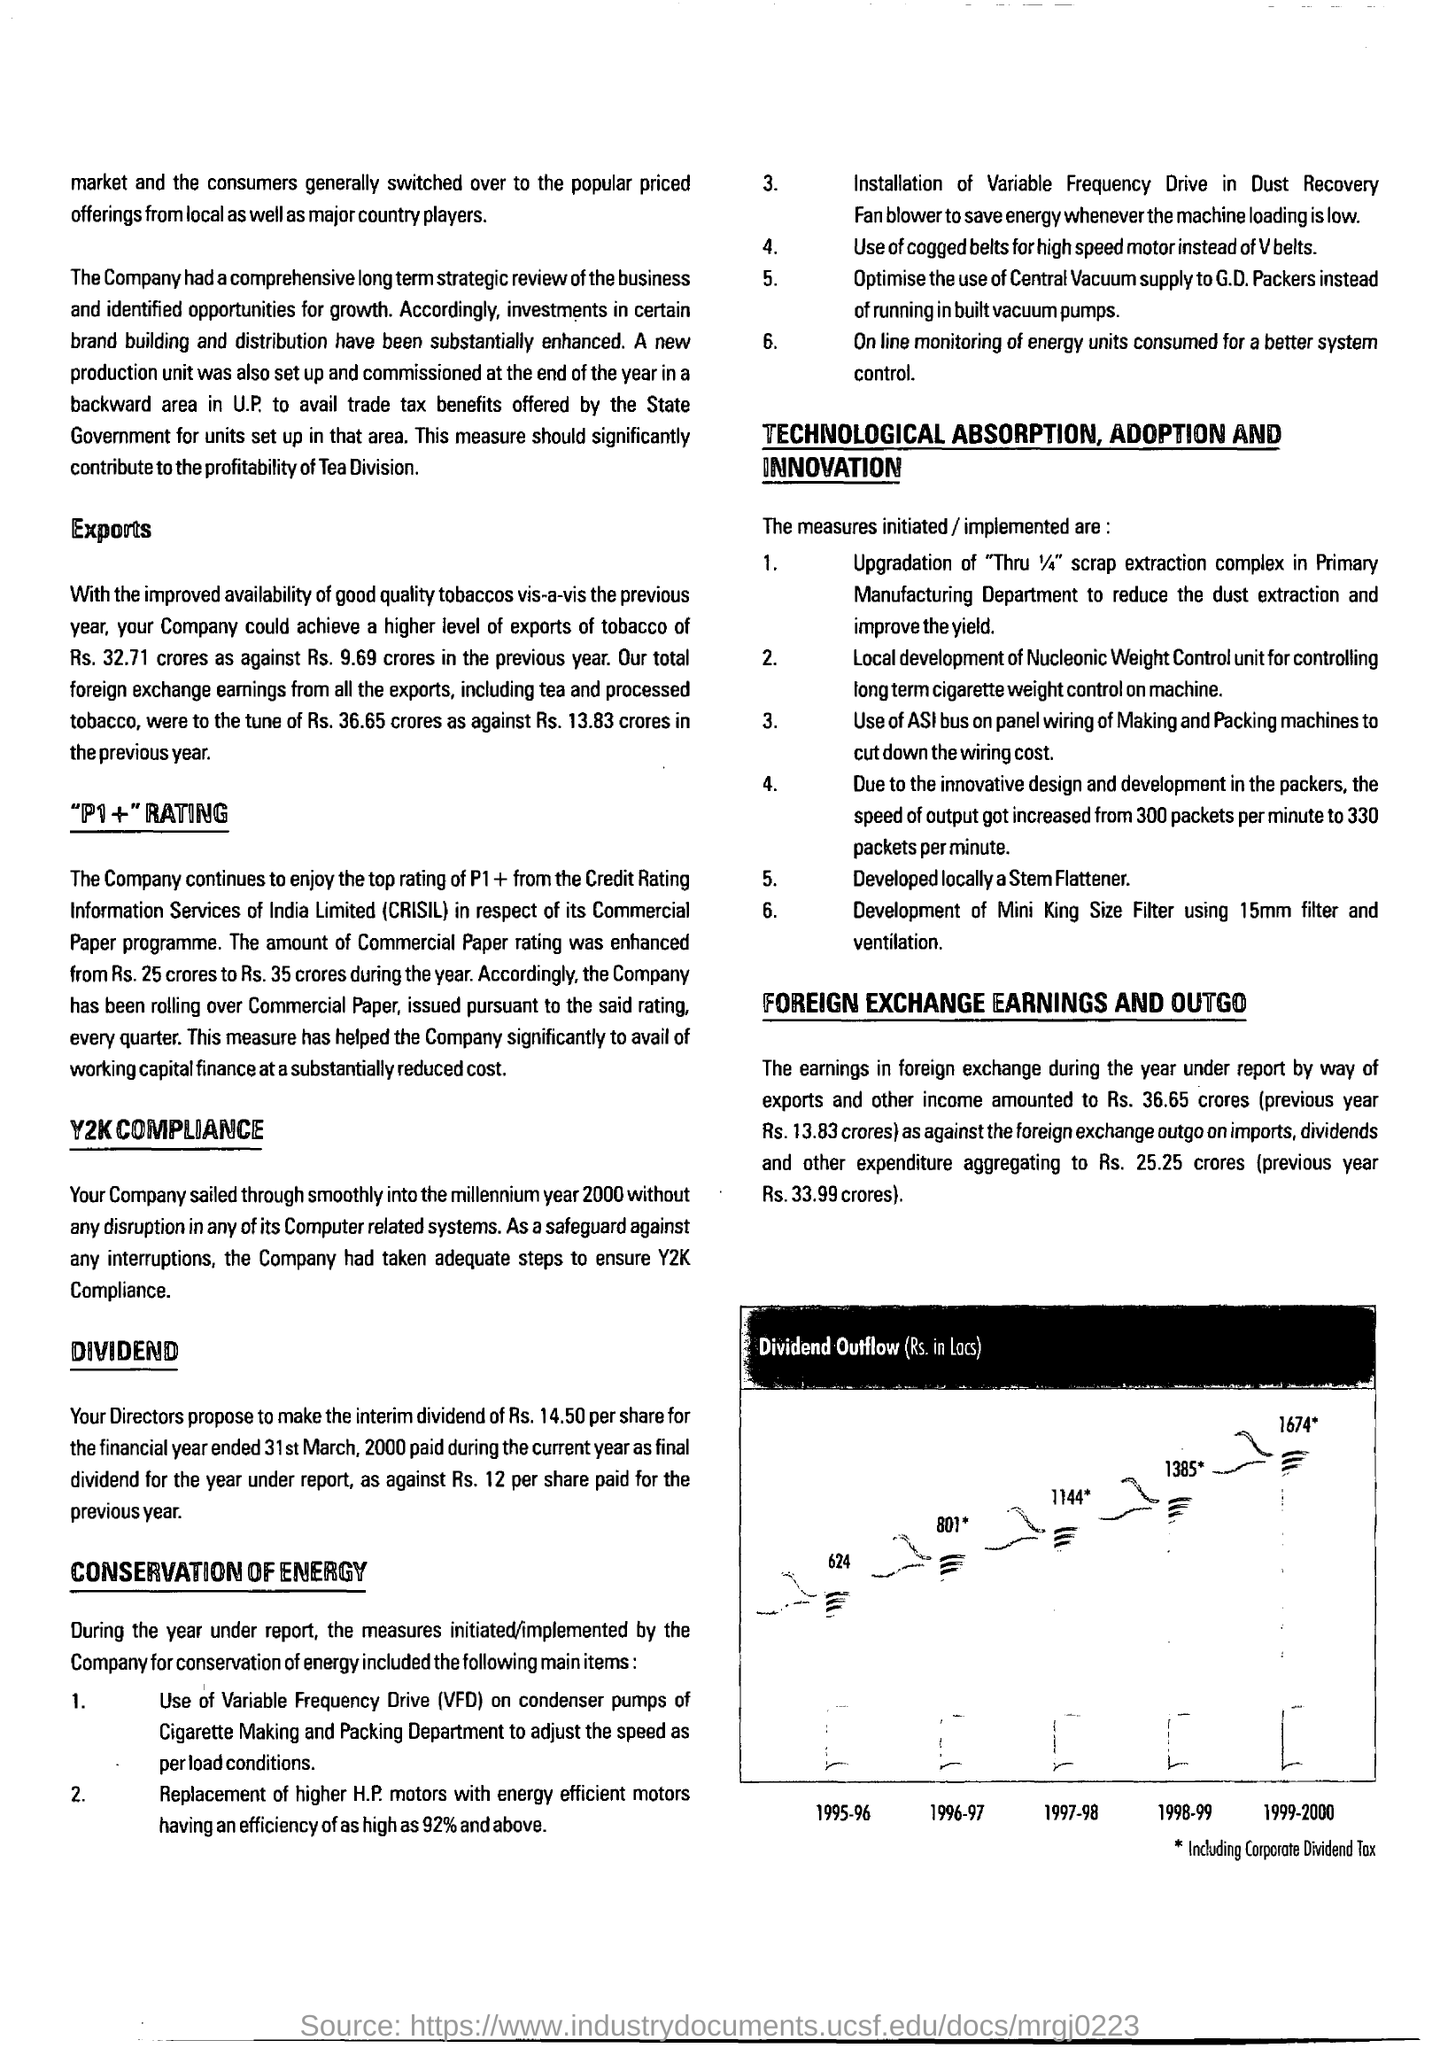Indicate a few pertinent items in this graphic. The first title in the document is 'EXPORTS.' 